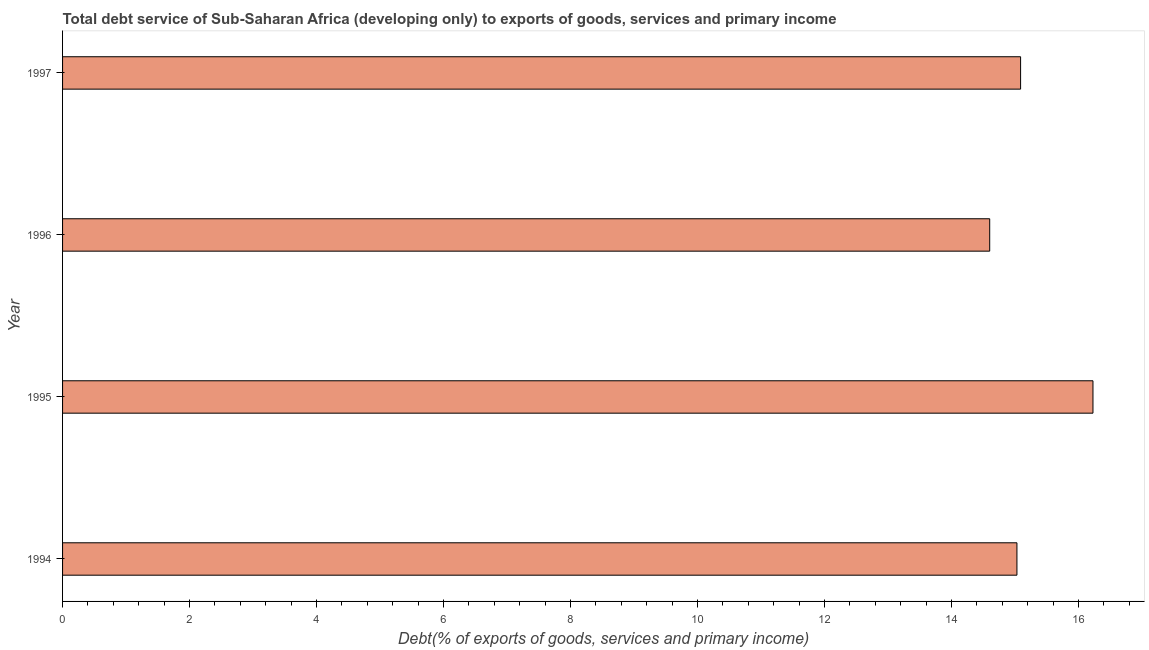Does the graph contain any zero values?
Ensure brevity in your answer.  No. What is the title of the graph?
Provide a short and direct response. Total debt service of Sub-Saharan Africa (developing only) to exports of goods, services and primary income. What is the label or title of the X-axis?
Make the answer very short. Debt(% of exports of goods, services and primary income). What is the label or title of the Y-axis?
Your response must be concise. Year. What is the total debt service in 1994?
Your answer should be very brief. 15.03. Across all years, what is the maximum total debt service?
Ensure brevity in your answer.  16.23. Across all years, what is the minimum total debt service?
Offer a very short reply. 14.6. In which year was the total debt service minimum?
Provide a short and direct response. 1996. What is the sum of the total debt service?
Your response must be concise. 60.95. What is the difference between the total debt service in 1994 and 1995?
Your answer should be compact. -1.2. What is the average total debt service per year?
Offer a very short reply. 15.24. What is the median total debt service?
Make the answer very short. 15.06. Do a majority of the years between 1994 and 1996 (inclusive) have total debt service greater than 4.4 %?
Offer a terse response. Yes. What is the ratio of the total debt service in 1994 to that in 1997?
Make the answer very short. 1. Is the total debt service in 1996 less than that in 1997?
Make the answer very short. Yes. What is the difference between the highest and the second highest total debt service?
Provide a short and direct response. 1.14. What is the difference between the highest and the lowest total debt service?
Give a very brief answer. 1.63. How many years are there in the graph?
Offer a very short reply. 4. Are the values on the major ticks of X-axis written in scientific E-notation?
Ensure brevity in your answer.  No. What is the Debt(% of exports of goods, services and primary income) in 1994?
Provide a short and direct response. 15.03. What is the Debt(% of exports of goods, services and primary income) in 1995?
Offer a very short reply. 16.23. What is the Debt(% of exports of goods, services and primary income) in 1996?
Keep it short and to the point. 14.6. What is the Debt(% of exports of goods, services and primary income) of 1997?
Provide a succinct answer. 15.09. What is the difference between the Debt(% of exports of goods, services and primary income) in 1994 and 1995?
Make the answer very short. -1.2. What is the difference between the Debt(% of exports of goods, services and primary income) in 1994 and 1996?
Give a very brief answer. 0.43. What is the difference between the Debt(% of exports of goods, services and primary income) in 1994 and 1997?
Make the answer very short. -0.06. What is the difference between the Debt(% of exports of goods, services and primary income) in 1995 and 1996?
Make the answer very short. 1.63. What is the difference between the Debt(% of exports of goods, services and primary income) in 1995 and 1997?
Provide a succinct answer. 1.14. What is the difference between the Debt(% of exports of goods, services and primary income) in 1996 and 1997?
Ensure brevity in your answer.  -0.49. What is the ratio of the Debt(% of exports of goods, services and primary income) in 1994 to that in 1995?
Provide a short and direct response. 0.93. What is the ratio of the Debt(% of exports of goods, services and primary income) in 1995 to that in 1996?
Your answer should be compact. 1.11. What is the ratio of the Debt(% of exports of goods, services and primary income) in 1995 to that in 1997?
Give a very brief answer. 1.08. What is the ratio of the Debt(% of exports of goods, services and primary income) in 1996 to that in 1997?
Offer a very short reply. 0.97. 